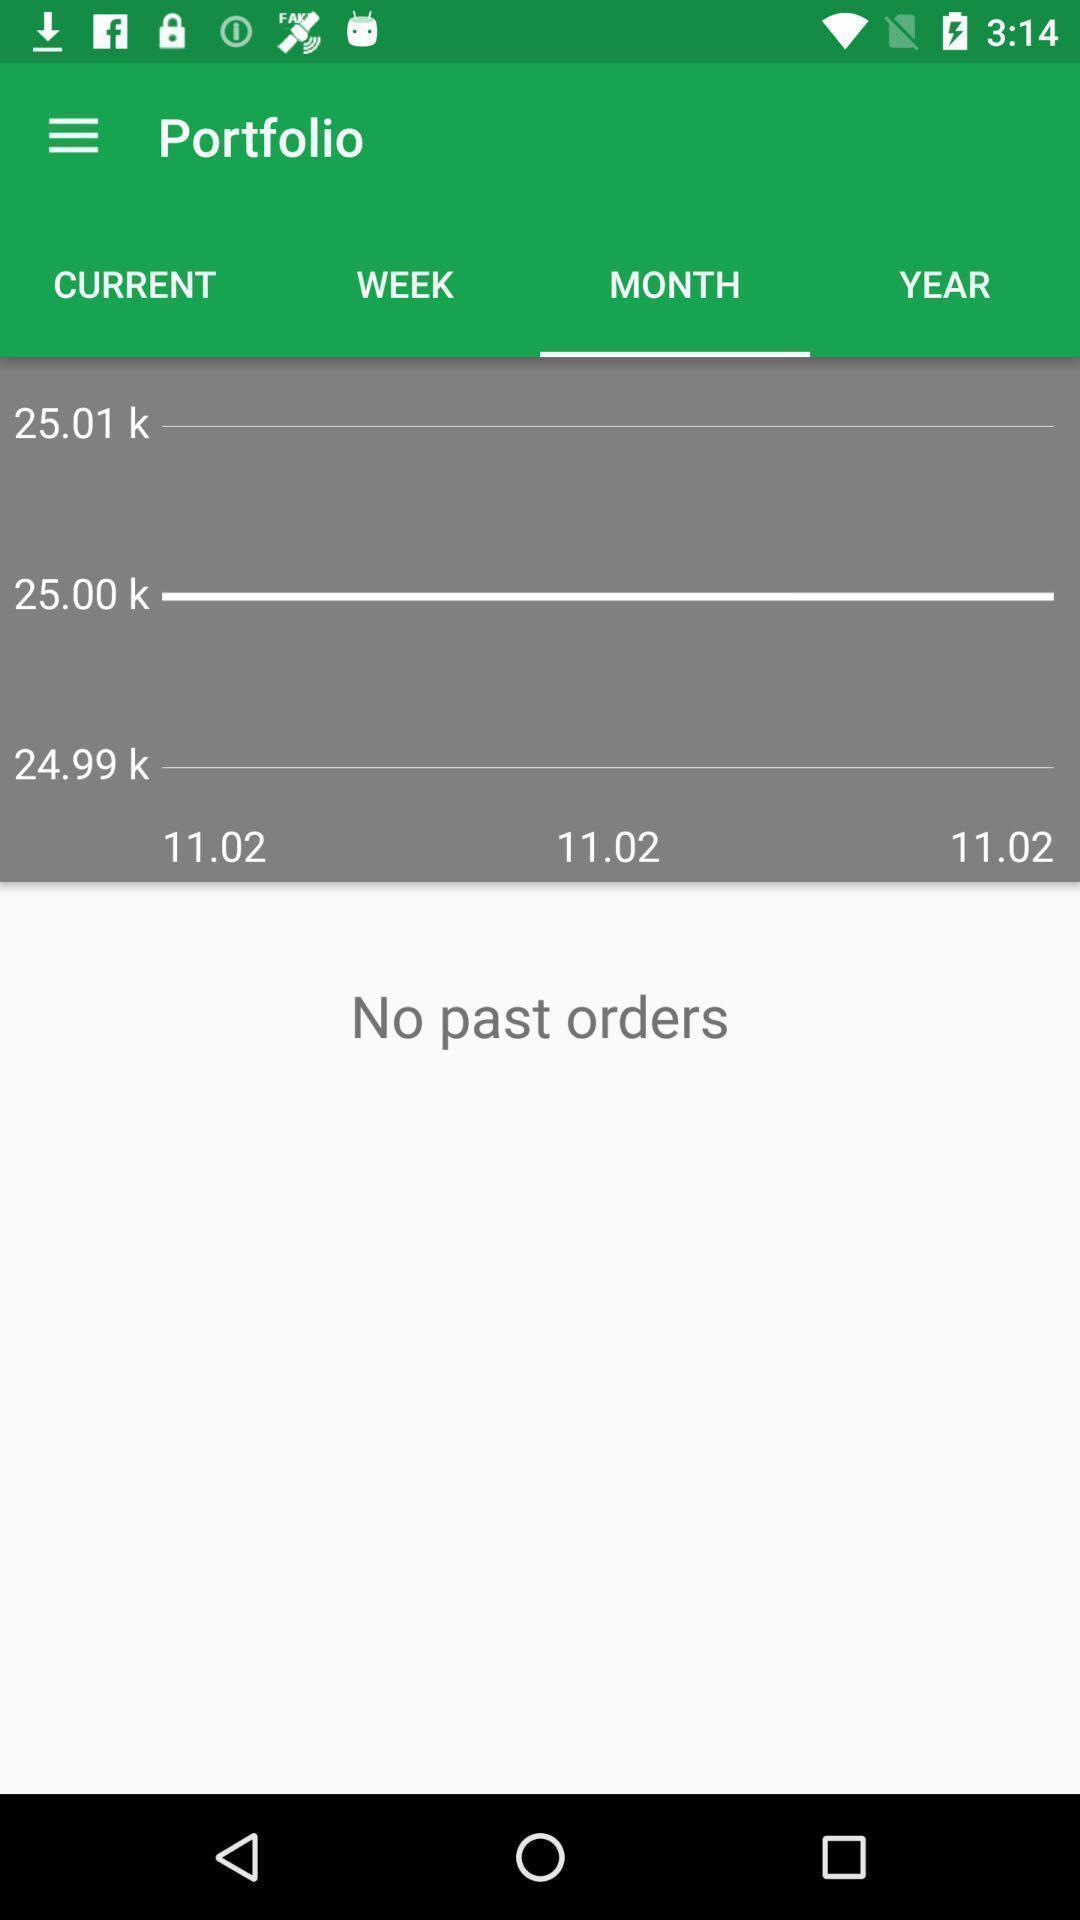What can you discern from this picture? Screen displaying the portfolio page. 